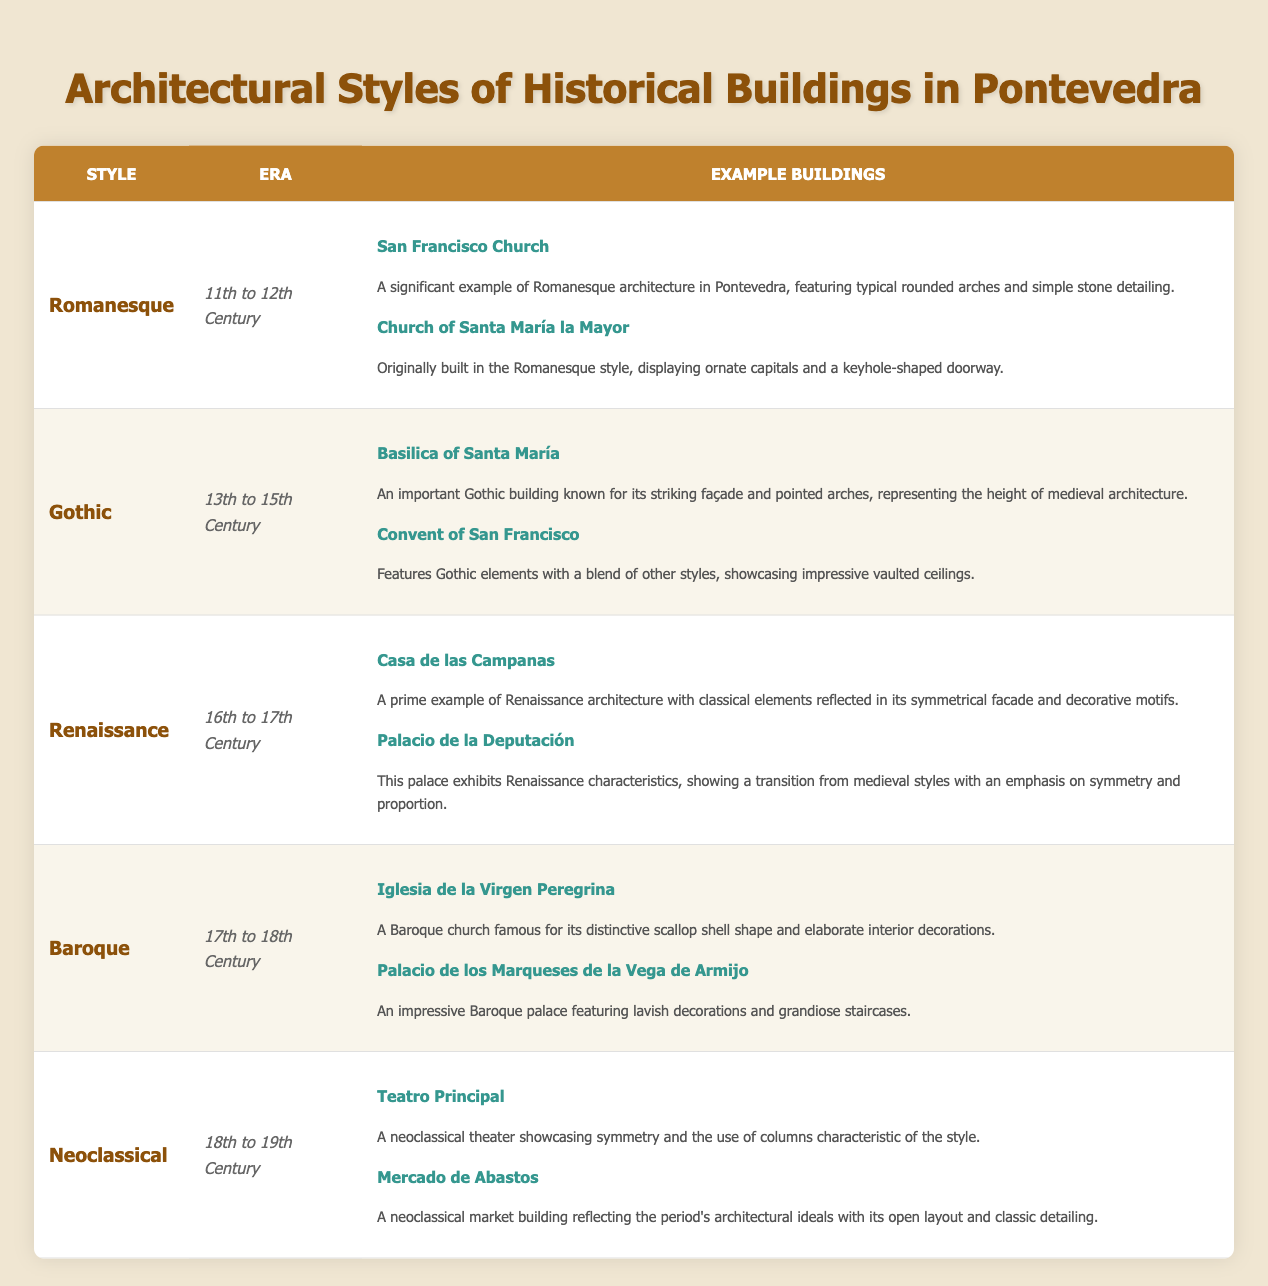What is the era of Gothic architecture in Pontevedra? The table lists the era of Gothic architecture as "13th to 15th Century" under the corresponding architectural style.
Answer: 13th to 15th Century Which building is an example of Romanesque architecture? The table provides "San Francisco Church" and "Church of Santa María la Mayor" as examples of Romanesque architecture.
Answer: San Francisco Church, Church of Santa María la Mayor How many architectural styles are listed in the table? The table includes five distinct architectural styles: Romanesque, Gothic, Renaissance, Baroque, and Neoclassical, so we count them directly from the table.
Answer: 5 Is the Basilica of Santa María a Baroque building? According to the table, the Basilica of Santa María is categorized under Gothic architecture, therefore, the claim is false.
Answer: No Which style spans the years from the 17th to the 18th century? The table indicates that the Baroque architectural style spans from the 17th to 18th century, as shown in the era column.
Answer: Baroque What two styles of architecture are found in the 18th to 19th century era? The table shows Neoclassical as the only style listed for the 18th to 19th century era, confirming that it is the only one for that period.
Answer: Neoclassical List the example buildings from the Renaissance period. By referring to the Renaissance section of the table, the examples include "Casa de las Campanas" and "Palacio de la Deputación."
Answer: Casa de las Campanas, Palacio de la Deputación How does the number of Gothic examples compare to Baroque examples? The Gothic style has two example buildings (Basilica of Santa María and Convent of San Francisco), and the Baroque style also has two examples (Iglesia de la Virgen Peregrina and Palacio de los Marqueses de la Vega de Armijo). Thus, both have the same number of examples.
Answer: They are equal Which architectural style had the longest duration based on the table? Evaluating the eras from the table, Gothic spans three centuries (13th to 15th) while Romanesque spans two (11th to 12th), so Gothic has the longest duration overall.
Answer: Gothic 